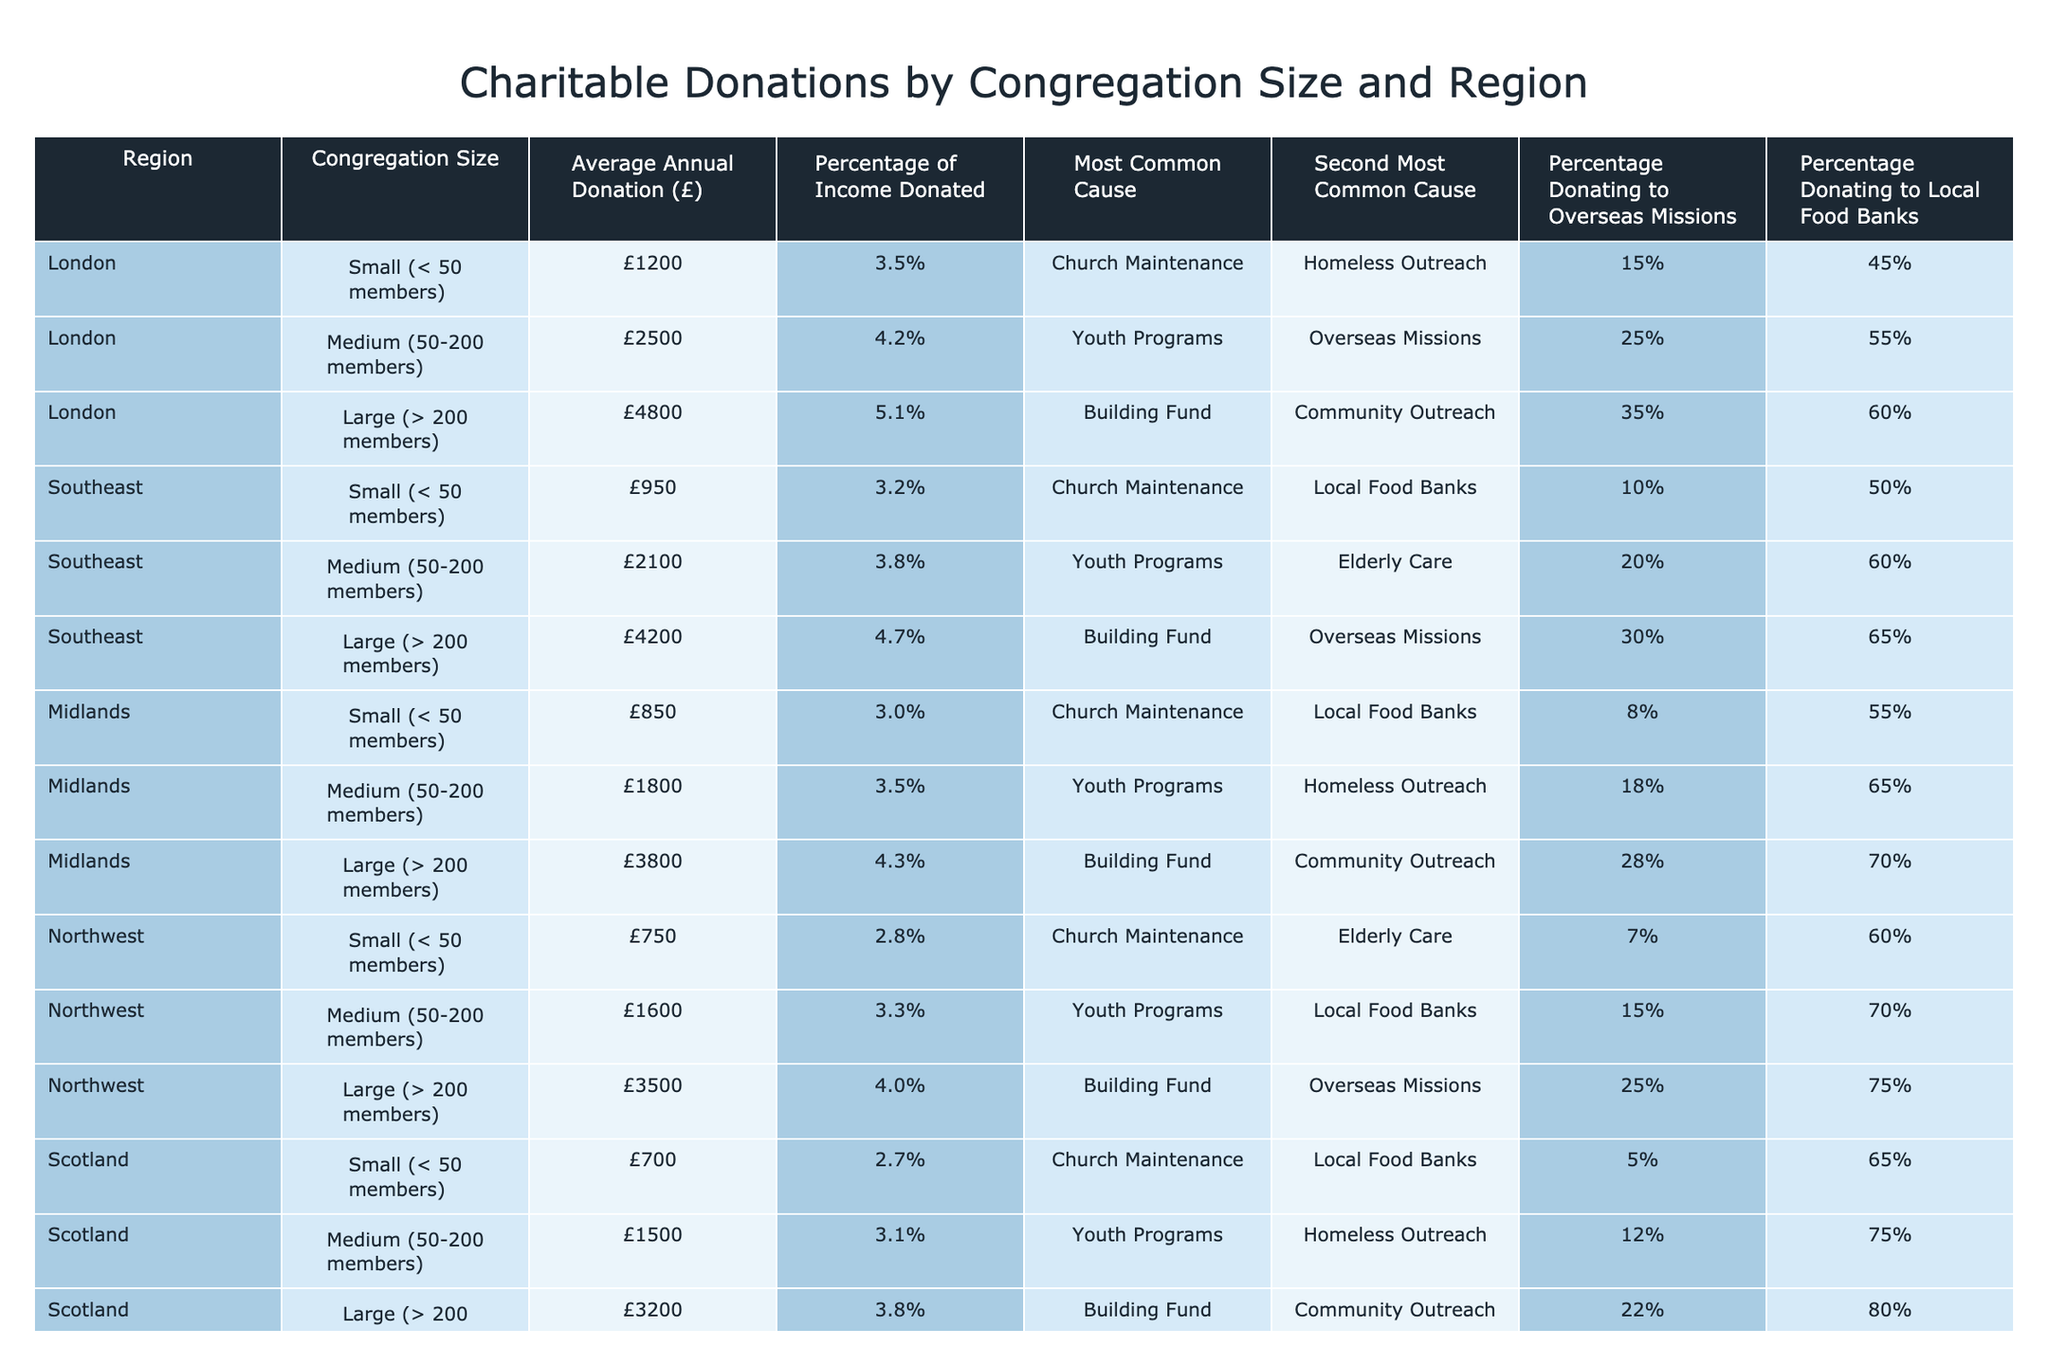What is the average annual donation for large congregations in the Southeast region? The average annual donation for large congregations in the Southeast is £4200, as indicated directly in the table.
Answer: £4200 Which region has the highest percentage of income donated by medium-sized congregations? The table shows that the largest percentage of income donated by medium-sized congregations is 4.2% in London.
Answer: 4.2% True or false: The percentage of congregations donating to local food banks in Scotland is the highest among the regions listed. Looking at the table, the highest percentage donating to local food banks is 80% in Wales, so the statement is false.
Answer: False What is the difference in average annual donations between small congregations in London and in the Northwest? The average annual donation for small congregations in London is £1200, and for the Northwest, it's £750. The difference is £1200 - £750 = £450.
Answer: £450 For large congregations, what is the most common cause supported in the Midlands? From the table, it is clear that the most common cause supported by large congregations in the Midlands is the Building Fund.
Answer: Building Fund What is the overall average annual donation for medium-sized congregations across all regions? To calculate this, we need the average of the medium-sized congregations: (2500 + 2100 + 1800 + 1600 + 1500 + 1400 + 1700) / 7 = 1900.
Answer: £1900 Which region has the highest total combination of the average annual donations for small congregations? The totals for small congregations are: London (£1200), Southeast (£950), Midlands (£850), Northwest (£750), Scotland (£700), Wales (£650), Northern Ireland (£800). London has the highest sum of £1200 among these groups.
Answer: London What percentage of large congregations in Wales donate to overseas missions? According to the table, 20% of large congregations in Wales donate to overseas missions.
Answer: 20% What is the average percentage of income donated by large congregations across all regions? The average of the percentages for large congregations is (5.1% + 4.7% + 4.3% + 4.0% + 3.8% + 3.6% + 4.1%) / 7 = 4.24%. Therefore, the average percentage is approximately 4.24%.
Answer: 4.24% For small congregations, which is the most common cause in Northern Ireland and what percentage of these congregations donate to local food banks? The most common cause for small congregations in Northern Ireland is Church Maintenance, and 75% of these congregations donate to local food banks.
Answer: Church Maintenance, 75% 